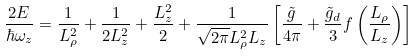Convert formula to latex. <formula><loc_0><loc_0><loc_500><loc_500>\frac { 2 E } { \hbar { \omega } _ { z } } = \frac { 1 } { L _ { \rho } ^ { 2 } } + \frac { 1 } { 2 L _ { z } ^ { 2 } } + \frac { L _ { z } ^ { 2 } } { 2 } + \frac { 1 } { \sqrt { 2 \pi } L _ { \rho } ^ { 2 } L _ { z } } \left [ \frac { \tilde { g } } { 4 \pi } + \frac { \tilde { g } _ { d } } { 3 } f \left ( \frac { L _ { \rho } } { L _ { z } } \right ) \right ]</formula> 